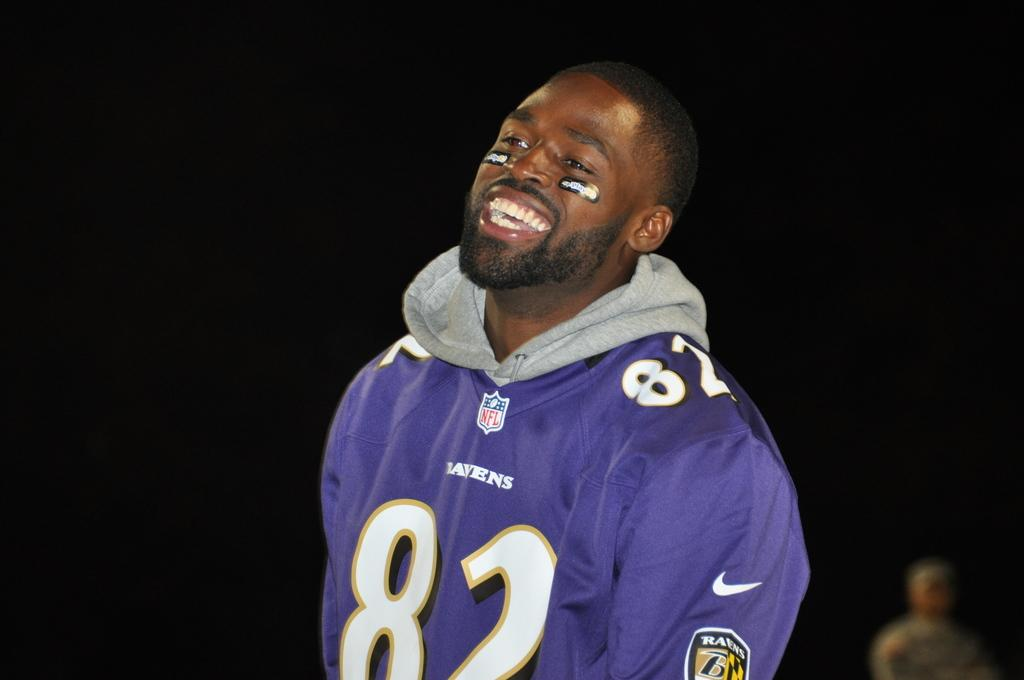<image>
Provide a brief description of the given image. man in a jersey with the number 82 written acrosss 